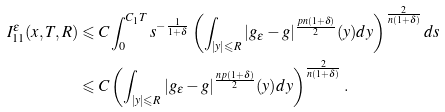<formula> <loc_0><loc_0><loc_500><loc_500>I ^ { \varepsilon } _ { 1 1 } ( x , T , R ) & \leqslant C \int _ { 0 } ^ { C _ { 1 } T } s ^ { - \frac { 1 } { 1 + \delta } } \left ( \int _ { | y | \leqslant R } | g _ { \varepsilon } - g | ^ { \frac { p n ( 1 + \delta ) } { 2 } } ( y ) d y \right ) ^ { \frac { 2 } { n ( 1 + \delta ) } } d s \\ & \leqslant C \left ( \int _ { | y | \leqslant R } | g _ { \varepsilon } - g | ^ { \frac { n p ( 1 + \delta ) } { 2 } } ( y ) d y \right ) ^ { \frac { 2 } { n ( 1 + \delta ) } } .</formula> 